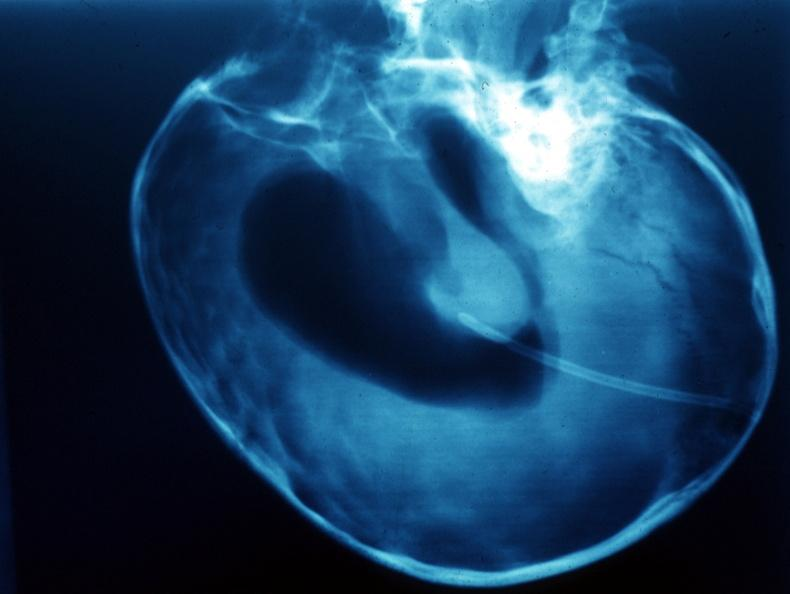s craniopharyngioma present?
Answer the question using a single word or phrase. Yes 